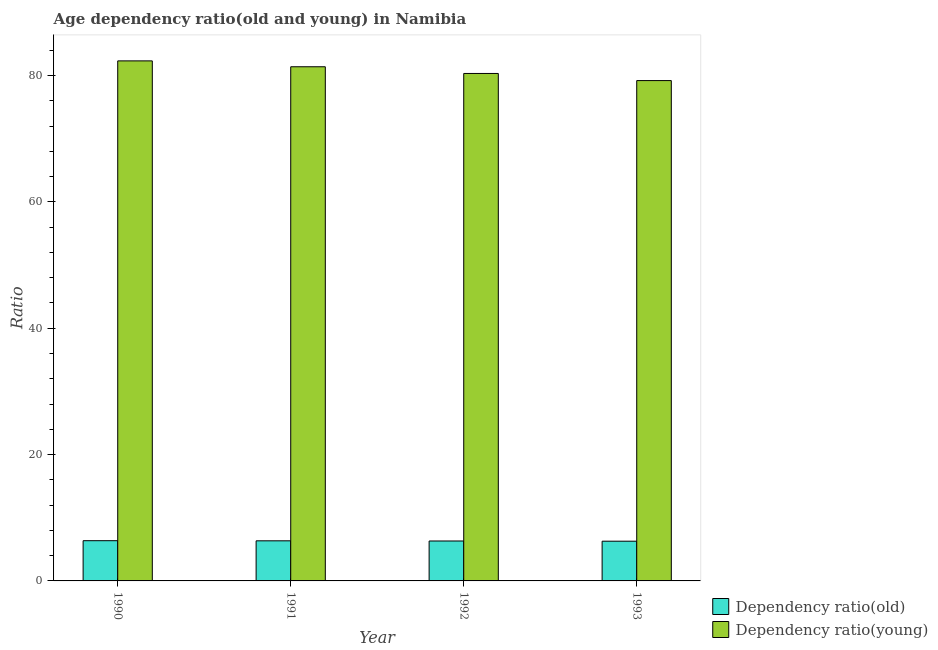How many different coloured bars are there?
Give a very brief answer. 2. Are the number of bars per tick equal to the number of legend labels?
Your answer should be compact. Yes. Are the number of bars on each tick of the X-axis equal?
Offer a very short reply. Yes. How many bars are there on the 2nd tick from the left?
Provide a short and direct response. 2. In how many cases, is the number of bars for a given year not equal to the number of legend labels?
Give a very brief answer. 0. What is the age dependency ratio(old) in 1993?
Provide a short and direct response. 6.29. Across all years, what is the maximum age dependency ratio(young)?
Your response must be concise. 82.32. Across all years, what is the minimum age dependency ratio(old)?
Keep it short and to the point. 6.29. What is the total age dependency ratio(young) in the graph?
Your answer should be compact. 323.24. What is the difference between the age dependency ratio(old) in 1992 and that in 1993?
Offer a very short reply. 0.03. What is the difference between the age dependency ratio(old) in 1990 and the age dependency ratio(young) in 1991?
Your response must be concise. 0.02. What is the average age dependency ratio(young) per year?
Your response must be concise. 80.81. What is the ratio of the age dependency ratio(young) in 1991 to that in 1992?
Offer a terse response. 1.01. Is the age dependency ratio(young) in 1991 less than that in 1992?
Provide a short and direct response. No. Is the difference between the age dependency ratio(young) in 1990 and 1992 greater than the difference between the age dependency ratio(old) in 1990 and 1992?
Keep it short and to the point. No. What is the difference between the highest and the second highest age dependency ratio(young)?
Offer a terse response. 0.93. What is the difference between the highest and the lowest age dependency ratio(young)?
Provide a short and direct response. 3.12. Is the sum of the age dependency ratio(old) in 1990 and 1992 greater than the maximum age dependency ratio(young) across all years?
Ensure brevity in your answer.  Yes. What does the 1st bar from the left in 1990 represents?
Your answer should be compact. Dependency ratio(old). What does the 2nd bar from the right in 1993 represents?
Your response must be concise. Dependency ratio(old). How many years are there in the graph?
Give a very brief answer. 4. Are the values on the major ticks of Y-axis written in scientific E-notation?
Your answer should be compact. No. Does the graph contain grids?
Provide a succinct answer. No. Where does the legend appear in the graph?
Your answer should be compact. Bottom right. How are the legend labels stacked?
Provide a short and direct response. Vertical. What is the title of the graph?
Offer a terse response. Age dependency ratio(old and young) in Namibia. What is the label or title of the Y-axis?
Offer a terse response. Ratio. What is the Ratio of Dependency ratio(old) in 1990?
Offer a terse response. 6.37. What is the Ratio in Dependency ratio(young) in 1990?
Offer a very short reply. 82.32. What is the Ratio of Dependency ratio(old) in 1991?
Ensure brevity in your answer.  6.35. What is the Ratio in Dependency ratio(young) in 1991?
Your answer should be very brief. 81.39. What is the Ratio of Dependency ratio(old) in 1992?
Your answer should be very brief. 6.32. What is the Ratio of Dependency ratio(young) in 1992?
Your response must be concise. 80.33. What is the Ratio in Dependency ratio(old) in 1993?
Keep it short and to the point. 6.29. What is the Ratio of Dependency ratio(young) in 1993?
Give a very brief answer. 79.2. Across all years, what is the maximum Ratio in Dependency ratio(old)?
Ensure brevity in your answer.  6.37. Across all years, what is the maximum Ratio of Dependency ratio(young)?
Make the answer very short. 82.32. Across all years, what is the minimum Ratio in Dependency ratio(old)?
Provide a short and direct response. 6.29. Across all years, what is the minimum Ratio of Dependency ratio(young)?
Your answer should be compact. 79.2. What is the total Ratio in Dependency ratio(old) in the graph?
Your answer should be compact. 25.33. What is the total Ratio in Dependency ratio(young) in the graph?
Offer a terse response. 323.24. What is the difference between the Ratio in Dependency ratio(old) in 1990 and that in 1991?
Provide a succinct answer. 0.02. What is the difference between the Ratio in Dependency ratio(young) in 1990 and that in 1991?
Offer a very short reply. 0.93. What is the difference between the Ratio of Dependency ratio(old) in 1990 and that in 1992?
Offer a terse response. 0.05. What is the difference between the Ratio of Dependency ratio(young) in 1990 and that in 1992?
Make the answer very short. 1.99. What is the difference between the Ratio in Dependency ratio(old) in 1990 and that in 1993?
Provide a succinct answer. 0.08. What is the difference between the Ratio in Dependency ratio(young) in 1990 and that in 1993?
Your answer should be very brief. 3.12. What is the difference between the Ratio in Dependency ratio(old) in 1991 and that in 1992?
Provide a succinct answer. 0.03. What is the difference between the Ratio in Dependency ratio(young) in 1991 and that in 1992?
Your answer should be compact. 1.06. What is the difference between the Ratio in Dependency ratio(old) in 1991 and that in 1993?
Ensure brevity in your answer.  0.06. What is the difference between the Ratio of Dependency ratio(young) in 1991 and that in 1993?
Ensure brevity in your answer.  2.19. What is the difference between the Ratio in Dependency ratio(old) in 1992 and that in 1993?
Offer a terse response. 0.03. What is the difference between the Ratio of Dependency ratio(young) in 1992 and that in 1993?
Offer a very short reply. 1.13. What is the difference between the Ratio of Dependency ratio(old) in 1990 and the Ratio of Dependency ratio(young) in 1991?
Your response must be concise. -75.02. What is the difference between the Ratio in Dependency ratio(old) in 1990 and the Ratio in Dependency ratio(young) in 1992?
Your answer should be compact. -73.96. What is the difference between the Ratio of Dependency ratio(old) in 1990 and the Ratio of Dependency ratio(young) in 1993?
Offer a terse response. -72.83. What is the difference between the Ratio of Dependency ratio(old) in 1991 and the Ratio of Dependency ratio(young) in 1992?
Offer a very short reply. -73.98. What is the difference between the Ratio in Dependency ratio(old) in 1991 and the Ratio in Dependency ratio(young) in 1993?
Your answer should be very brief. -72.85. What is the difference between the Ratio of Dependency ratio(old) in 1992 and the Ratio of Dependency ratio(young) in 1993?
Your answer should be very brief. -72.88. What is the average Ratio of Dependency ratio(old) per year?
Ensure brevity in your answer.  6.33. What is the average Ratio of Dependency ratio(young) per year?
Offer a terse response. 80.81. In the year 1990, what is the difference between the Ratio of Dependency ratio(old) and Ratio of Dependency ratio(young)?
Offer a very short reply. -75.95. In the year 1991, what is the difference between the Ratio in Dependency ratio(old) and Ratio in Dependency ratio(young)?
Ensure brevity in your answer.  -75.04. In the year 1992, what is the difference between the Ratio in Dependency ratio(old) and Ratio in Dependency ratio(young)?
Make the answer very short. -74.01. In the year 1993, what is the difference between the Ratio in Dependency ratio(old) and Ratio in Dependency ratio(young)?
Your answer should be very brief. -72.91. What is the ratio of the Ratio in Dependency ratio(old) in 1990 to that in 1991?
Offer a very short reply. 1. What is the ratio of the Ratio of Dependency ratio(young) in 1990 to that in 1991?
Give a very brief answer. 1.01. What is the ratio of the Ratio of Dependency ratio(old) in 1990 to that in 1992?
Make the answer very short. 1.01. What is the ratio of the Ratio of Dependency ratio(young) in 1990 to that in 1992?
Ensure brevity in your answer.  1.02. What is the ratio of the Ratio of Dependency ratio(old) in 1990 to that in 1993?
Your answer should be very brief. 1.01. What is the ratio of the Ratio of Dependency ratio(young) in 1990 to that in 1993?
Offer a terse response. 1.04. What is the ratio of the Ratio of Dependency ratio(old) in 1991 to that in 1992?
Ensure brevity in your answer.  1. What is the ratio of the Ratio of Dependency ratio(young) in 1991 to that in 1992?
Your answer should be very brief. 1.01. What is the ratio of the Ratio of Dependency ratio(old) in 1991 to that in 1993?
Your answer should be very brief. 1.01. What is the ratio of the Ratio in Dependency ratio(young) in 1991 to that in 1993?
Offer a terse response. 1.03. What is the ratio of the Ratio in Dependency ratio(old) in 1992 to that in 1993?
Keep it short and to the point. 1.01. What is the ratio of the Ratio in Dependency ratio(young) in 1992 to that in 1993?
Offer a terse response. 1.01. What is the difference between the highest and the second highest Ratio of Dependency ratio(old)?
Provide a succinct answer. 0.02. What is the difference between the highest and the second highest Ratio in Dependency ratio(young)?
Offer a terse response. 0.93. What is the difference between the highest and the lowest Ratio of Dependency ratio(old)?
Provide a succinct answer. 0.08. What is the difference between the highest and the lowest Ratio of Dependency ratio(young)?
Keep it short and to the point. 3.12. 